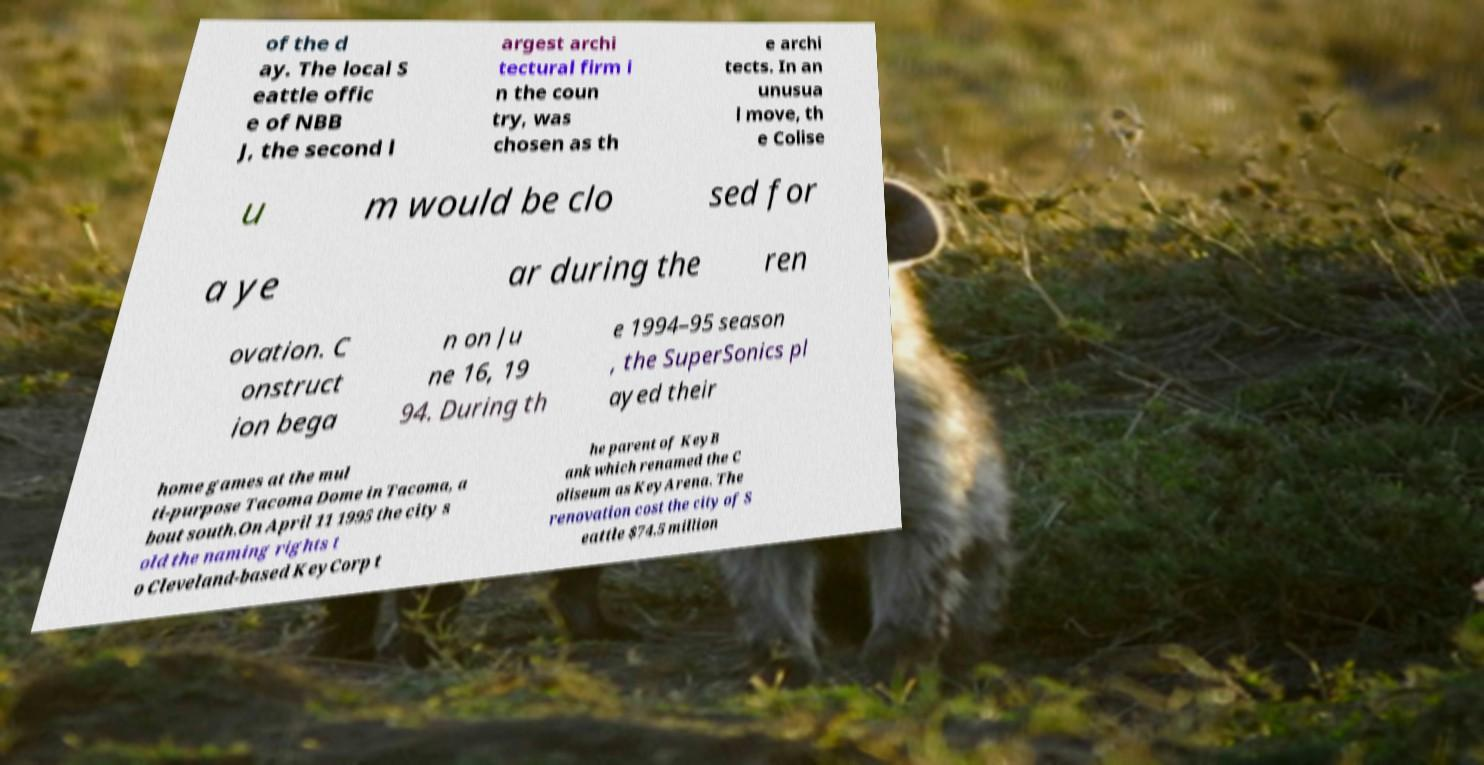Can you read and provide the text displayed in the image?This photo seems to have some interesting text. Can you extract and type it out for me? of the d ay. The local S eattle offic e of NBB J, the second l argest archi tectural firm i n the coun try, was chosen as th e archi tects. In an unusua l move, th e Colise u m would be clo sed for a ye ar during the ren ovation. C onstruct ion bega n on Ju ne 16, 19 94. During th e 1994–95 season , the SuperSonics pl ayed their home games at the mul ti-purpose Tacoma Dome in Tacoma, a bout south.On April 11 1995 the city s old the naming rights t o Cleveland-based KeyCorp t he parent of KeyB ank which renamed the C oliseum as KeyArena. The renovation cost the city of S eattle $74.5 million 